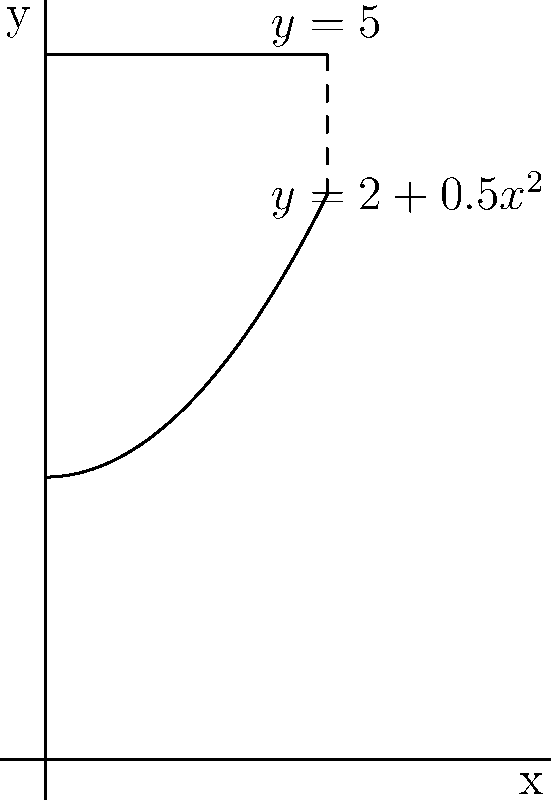As a skeptical homeowner interested in sustainable water management, you're considering installing a cylindrical rainwater harvesting tank. The tank's radius (in meters) varies with height according to the function $r(h) = \sqrt{4+h^2}$, where $h$ is the height from the bottom of the tank. If the tank is 3 meters tall, calculate its volume using integration. How much rainwater could this tank potentially store? Let's approach this step-by-step:

1) The volume of a cylinder is given by the formula $V = \pi r^2 h$. However, in this case, the radius varies with height.

2) We need to use integration to calculate the volume. The formula becomes:
   $V = \int_0^3 \pi [r(h)]^2 dh$

3) Substituting the given function for $r(h)$:
   $V = \int_0^3 \pi (\sqrt{4+h^2})^2 dh$

4) Simplify the integrand:
   $V = \pi \int_0^3 (4+h^2) dh$

5) Integrate:
   $V = \pi [4h + \frac{1}{3}h^3]_0^3$

6) Evaluate the integral:
   $V = \pi [(4(3) + \frac{1}{3}(3)^3) - (4(0) + \frac{1}{3}(0)^3)]$
   $V = \pi [12 + 9 - 0]$
   $V = 21\pi$ cubic meters

7) Convert to liters (1 cubic meter = 1000 liters):
   $V = 21\pi * 1000 \approx 65,973$ liters

This tank could potentially store about 65,973 liters of rainwater, which is a significant amount for sustainable home water use.
Answer: $65,973$ liters 